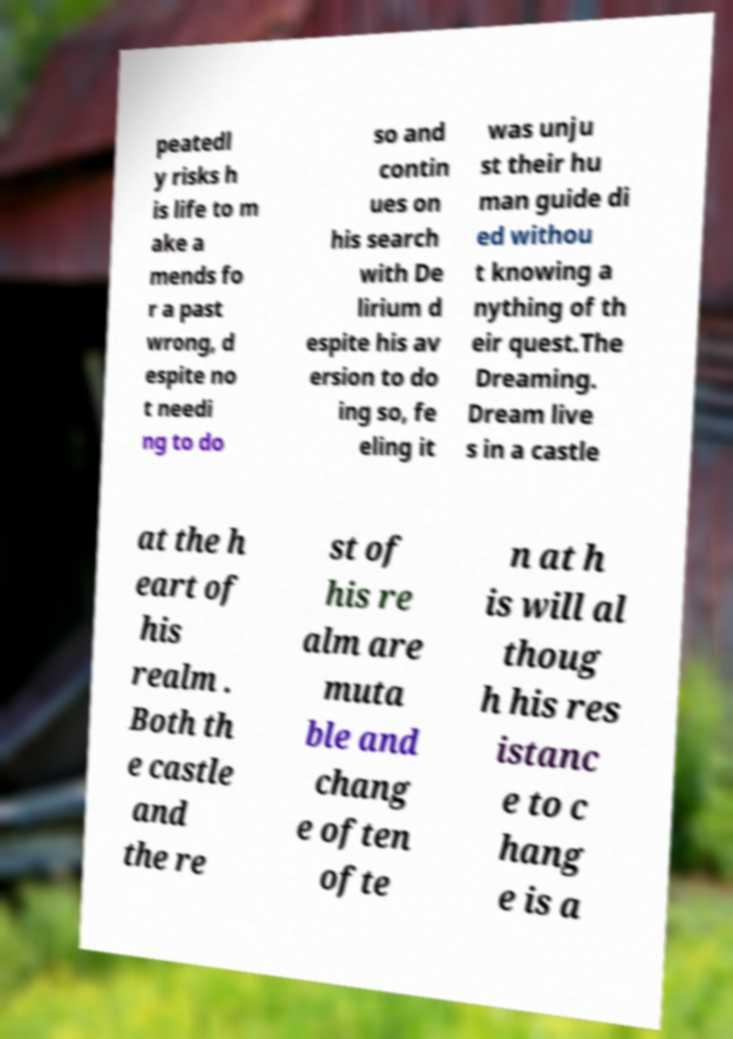For documentation purposes, I need the text within this image transcribed. Could you provide that? peatedl y risks h is life to m ake a mends fo r a past wrong, d espite no t needi ng to do so and contin ues on his search with De lirium d espite his av ersion to do ing so, fe eling it was unju st their hu man guide di ed withou t knowing a nything of th eir quest.The Dreaming. Dream live s in a castle at the h eart of his realm . Both th e castle and the re st of his re alm are muta ble and chang e often ofte n at h is will al thoug h his res istanc e to c hang e is a 